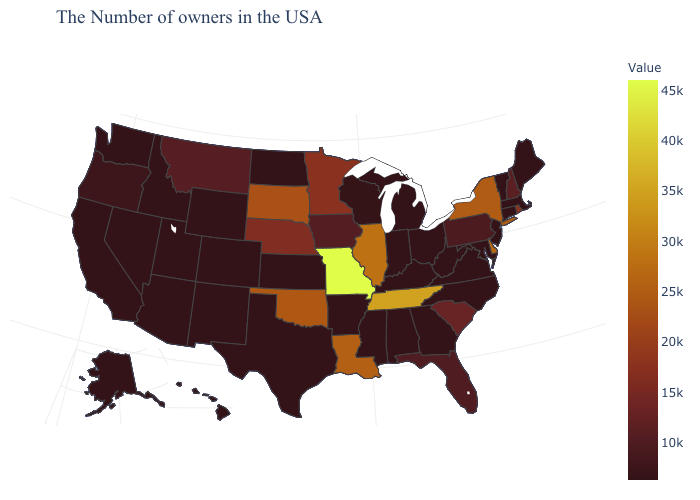Which states have the highest value in the USA?
Quick response, please. Missouri. Does Louisiana have the lowest value in the USA?
Short answer required. No. Among the states that border Illinois , does Kentucky have the lowest value?
Keep it brief. Yes. Which states hav the highest value in the MidWest?
Keep it brief. Missouri. Among the states that border California , which have the lowest value?
Keep it brief. Arizona, Nevada. Does the map have missing data?
Be succinct. No. Is the legend a continuous bar?
Write a very short answer. Yes. 